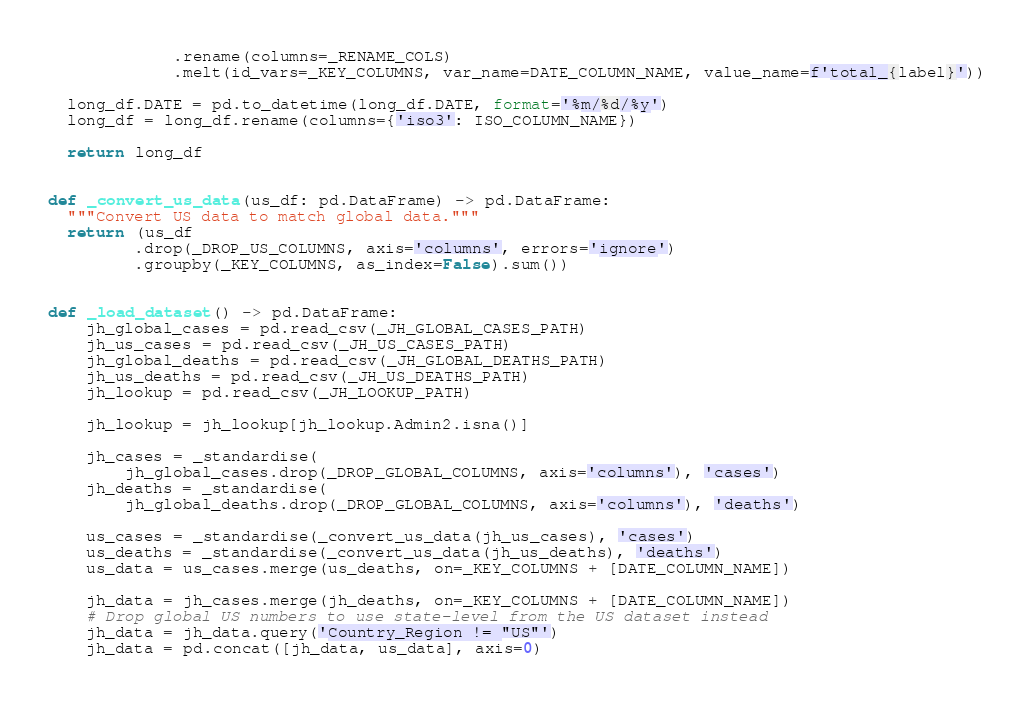Convert code to text. <code><loc_0><loc_0><loc_500><loc_500><_Python_>             .rename(columns=_RENAME_COLS)
             .melt(id_vars=_KEY_COLUMNS, var_name=DATE_COLUMN_NAME, value_name=f'total_{label}'))

  long_df.DATE = pd.to_datetime(long_df.DATE, format='%m/%d/%y')
  long_df = long_df.rename(columns={'iso3': ISO_COLUMN_NAME})

  return long_df 


def _convert_us_data(us_df: pd.DataFrame) -> pd.DataFrame:
  """Convert US data to match global data."""
  return (us_df
         .drop(_DROP_US_COLUMNS, axis='columns', errors='ignore')
         .groupby(_KEY_COLUMNS, as_index=False).sum())


def _load_dataset() -> pd.DataFrame:
    jh_global_cases = pd.read_csv(_JH_GLOBAL_CASES_PATH)
    jh_us_cases = pd.read_csv(_JH_US_CASES_PATH)
    jh_global_deaths = pd.read_csv(_JH_GLOBAL_DEATHS_PATH)
    jh_us_deaths = pd.read_csv(_JH_US_DEATHS_PATH)
    jh_lookup = pd.read_csv(_JH_LOOKUP_PATH)

    jh_lookup = jh_lookup[jh_lookup.Admin2.isna()]

    jh_cases = _standardise(
        jh_global_cases.drop(_DROP_GLOBAL_COLUMNS, axis='columns'), 'cases')
    jh_deaths = _standardise(
        jh_global_deaths.drop(_DROP_GLOBAL_COLUMNS, axis='columns'), 'deaths')

    us_cases = _standardise(_convert_us_data(jh_us_cases), 'cases')
    us_deaths = _standardise(_convert_us_data(jh_us_deaths), 'deaths')
    us_data = us_cases.merge(us_deaths, on=_KEY_COLUMNS + [DATE_COLUMN_NAME])

    jh_data = jh_cases.merge(jh_deaths, on=_KEY_COLUMNS + [DATE_COLUMN_NAME])
    # Drop global US numbers to use state-level from the US dataset instead
    jh_data = jh_data.query('Country_Region != "US"')  
    jh_data = pd.concat([jh_data, us_data], axis=0)</code> 